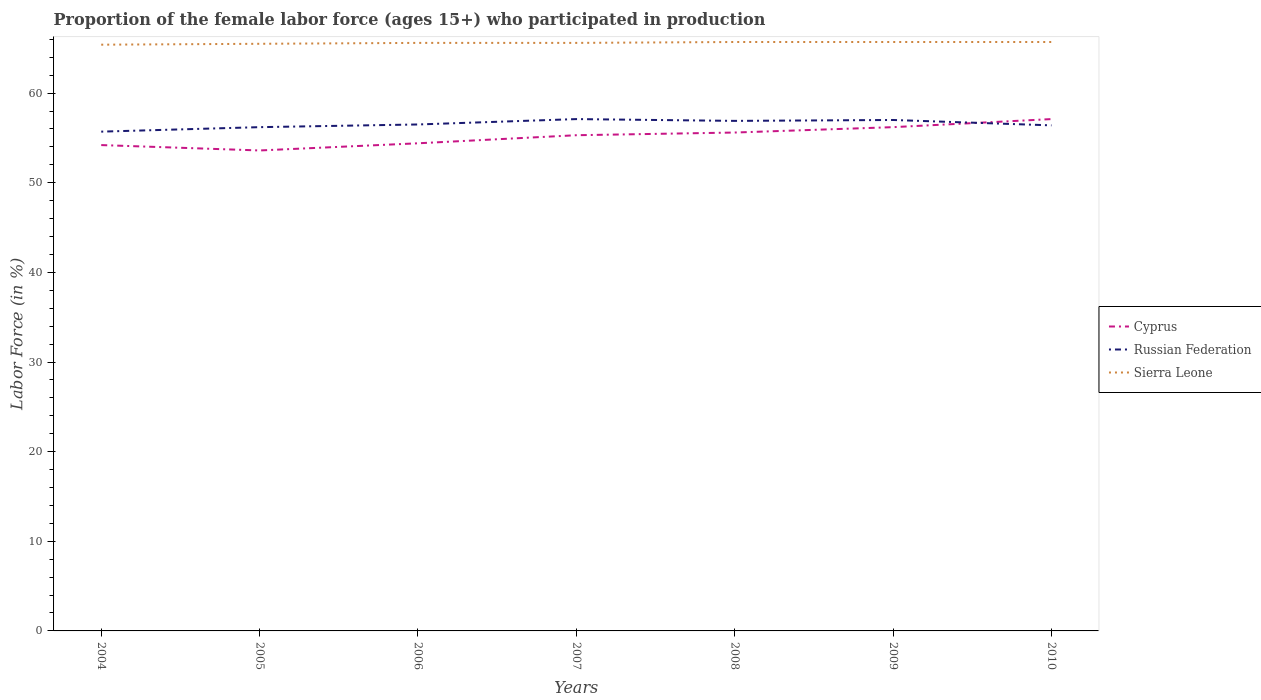How many different coloured lines are there?
Your answer should be very brief. 3. Across all years, what is the maximum proportion of the female labor force who participated in production in Russian Federation?
Keep it short and to the point. 55.7. In which year was the proportion of the female labor force who participated in production in Sierra Leone maximum?
Keep it short and to the point. 2004. What is the difference between the highest and the second highest proportion of the female labor force who participated in production in Cyprus?
Keep it short and to the point. 3.5. Is the proportion of the female labor force who participated in production in Cyprus strictly greater than the proportion of the female labor force who participated in production in Sierra Leone over the years?
Provide a short and direct response. Yes. How many lines are there?
Offer a terse response. 3. How many years are there in the graph?
Ensure brevity in your answer.  7. Are the values on the major ticks of Y-axis written in scientific E-notation?
Your answer should be compact. No. Does the graph contain grids?
Ensure brevity in your answer.  No. How are the legend labels stacked?
Provide a succinct answer. Vertical. What is the title of the graph?
Make the answer very short. Proportion of the female labor force (ages 15+) who participated in production. Does "United States" appear as one of the legend labels in the graph?
Offer a terse response. No. What is the label or title of the X-axis?
Your answer should be very brief. Years. What is the Labor Force (in %) in Cyprus in 2004?
Make the answer very short. 54.2. What is the Labor Force (in %) of Russian Federation in 2004?
Your response must be concise. 55.7. What is the Labor Force (in %) of Sierra Leone in 2004?
Your response must be concise. 65.4. What is the Labor Force (in %) of Cyprus in 2005?
Your answer should be compact. 53.6. What is the Labor Force (in %) in Russian Federation in 2005?
Your answer should be compact. 56.2. What is the Labor Force (in %) of Sierra Leone in 2005?
Provide a succinct answer. 65.5. What is the Labor Force (in %) of Cyprus in 2006?
Make the answer very short. 54.4. What is the Labor Force (in %) of Russian Federation in 2006?
Give a very brief answer. 56.5. What is the Labor Force (in %) in Sierra Leone in 2006?
Your answer should be compact. 65.6. What is the Labor Force (in %) in Cyprus in 2007?
Ensure brevity in your answer.  55.3. What is the Labor Force (in %) of Russian Federation in 2007?
Your answer should be compact. 57.1. What is the Labor Force (in %) in Sierra Leone in 2007?
Ensure brevity in your answer.  65.6. What is the Labor Force (in %) in Cyprus in 2008?
Make the answer very short. 55.6. What is the Labor Force (in %) in Russian Federation in 2008?
Make the answer very short. 56.9. What is the Labor Force (in %) of Sierra Leone in 2008?
Provide a succinct answer. 65.7. What is the Labor Force (in %) in Cyprus in 2009?
Offer a terse response. 56.2. What is the Labor Force (in %) of Sierra Leone in 2009?
Your answer should be compact. 65.7. What is the Labor Force (in %) in Cyprus in 2010?
Ensure brevity in your answer.  57.1. What is the Labor Force (in %) of Russian Federation in 2010?
Your answer should be compact. 56.4. What is the Labor Force (in %) of Sierra Leone in 2010?
Keep it short and to the point. 65.7. Across all years, what is the maximum Labor Force (in %) of Cyprus?
Provide a succinct answer. 57.1. Across all years, what is the maximum Labor Force (in %) in Russian Federation?
Offer a very short reply. 57.1. Across all years, what is the maximum Labor Force (in %) of Sierra Leone?
Your response must be concise. 65.7. Across all years, what is the minimum Labor Force (in %) in Cyprus?
Provide a succinct answer. 53.6. Across all years, what is the minimum Labor Force (in %) of Russian Federation?
Provide a short and direct response. 55.7. Across all years, what is the minimum Labor Force (in %) of Sierra Leone?
Give a very brief answer. 65.4. What is the total Labor Force (in %) of Cyprus in the graph?
Give a very brief answer. 386.4. What is the total Labor Force (in %) of Russian Federation in the graph?
Your answer should be very brief. 395.8. What is the total Labor Force (in %) in Sierra Leone in the graph?
Offer a very short reply. 459.2. What is the difference between the Labor Force (in %) in Cyprus in 2004 and that in 2005?
Offer a terse response. 0.6. What is the difference between the Labor Force (in %) in Sierra Leone in 2004 and that in 2005?
Give a very brief answer. -0.1. What is the difference between the Labor Force (in %) in Sierra Leone in 2004 and that in 2006?
Your answer should be very brief. -0.2. What is the difference between the Labor Force (in %) of Russian Federation in 2004 and that in 2009?
Keep it short and to the point. -1.3. What is the difference between the Labor Force (in %) in Cyprus in 2004 and that in 2010?
Offer a terse response. -2.9. What is the difference between the Labor Force (in %) in Sierra Leone in 2004 and that in 2010?
Offer a terse response. -0.3. What is the difference between the Labor Force (in %) of Cyprus in 2005 and that in 2006?
Make the answer very short. -0.8. What is the difference between the Labor Force (in %) in Cyprus in 2005 and that in 2007?
Your answer should be compact. -1.7. What is the difference between the Labor Force (in %) of Cyprus in 2005 and that in 2008?
Your answer should be very brief. -2. What is the difference between the Labor Force (in %) of Russian Federation in 2005 and that in 2008?
Give a very brief answer. -0.7. What is the difference between the Labor Force (in %) in Sierra Leone in 2005 and that in 2008?
Offer a terse response. -0.2. What is the difference between the Labor Force (in %) of Russian Federation in 2005 and that in 2010?
Provide a short and direct response. -0.2. What is the difference between the Labor Force (in %) of Cyprus in 2006 and that in 2008?
Provide a succinct answer. -1.2. What is the difference between the Labor Force (in %) of Russian Federation in 2006 and that in 2009?
Provide a succinct answer. -0.5. What is the difference between the Labor Force (in %) in Cyprus in 2006 and that in 2010?
Offer a terse response. -2.7. What is the difference between the Labor Force (in %) in Russian Federation in 2006 and that in 2010?
Make the answer very short. 0.1. What is the difference between the Labor Force (in %) of Cyprus in 2007 and that in 2008?
Your answer should be very brief. -0.3. What is the difference between the Labor Force (in %) of Russian Federation in 2007 and that in 2008?
Keep it short and to the point. 0.2. What is the difference between the Labor Force (in %) in Cyprus in 2007 and that in 2009?
Ensure brevity in your answer.  -0.9. What is the difference between the Labor Force (in %) in Russian Federation in 2007 and that in 2009?
Keep it short and to the point. 0.1. What is the difference between the Labor Force (in %) in Sierra Leone in 2007 and that in 2010?
Provide a short and direct response. -0.1. What is the difference between the Labor Force (in %) of Cyprus in 2008 and that in 2009?
Your answer should be compact. -0.6. What is the difference between the Labor Force (in %) of Sierra Leone in 2008 and that in 2009?
Your answer should be very brief. 0. What is the difference between the Labor Force (in %) of Cyprus in 2008 and that in 2010?
Offer a very short reply. -1.5. What is the difference between the Labor Force (in %) of Russian Federation in 2008 and that in 2010?
Offer a very short reply. 0.5. What is the difference between the Labor Force (in %) of Sierra Leone in 2008 and that in 2010?
Provide a succinct answer. 0. What is the difference between the Labor Force (in %) of Cyprus in 2009 and that in 2010?
Your response must be concise. -0.9. What is the difference between the Labor Force (in %) in Cyprus in 2004 and the Labor Force (in %) in Russian Federation in 2006?
Your answer should be very brief. -2.3. What is the difference between the Labor Force (in %) of Cyprus in 2004 and the Labor Force (in %) of Russian Federation in 2007?
Provide a succinct answer. -2.9. What is the difference between the Labor Force (in %) in Russian Federation in 2004 and the Labor Force (in %) in Sierra Leone in 2007?
Provide a succinct answer. -9.9. What is the difference between the Labor Force (in %) in Cyprus in 2004 and the Labor Force (in %) in Russian Federation in 2008?
Give a very brief answer. -2.7. What is the difference between the Labor Force (in %) in Cyprus in 2004 and the Labor Force (in %) in Sierra Leone in 2009?
Make the answer very short. -11.5. What is the difference between the Labor Force (in %) in Russian Federation in 2004 and the Labor Force (in %) in Sierra Leone in 2010?
Provide a succinct answer. -10. What is the difference between the Labor Force (in %) in Cyprus in 2005 and the Labor Force (in %) in Sierra Leone in 2007?
Your answer should be compact. -12. What is the difference between the Labor Force (in %) of Russian Federation in 2005 and the Labor Force (in %) of Sierra Leone in 2007?
Give a very brief answer. -9.4. What is the difference between the Labor Force (in %) in Russian Federation in 2005 and the Labor Force (in %) in Sierra Leone in 2008?
Your response must be concise. -9.5. What is the difference between the Labor Force (in %) in Cyprus in 2005 and the Labor Force (in %) in Sierra Leone in 2009?
Your response must be concise. -12.1. What is the difference between the Labor Force (in %) of Cyprus in 2005 and the Labor Force (in %) of Russian Federation in 2010?
Your answer should be compact. -2.8. What is the difference between the Labor Force (in %) in Cyprus in 2006 and the Labor Force (in %) in Russian Federation in 2007?
Keep it short and to the point. -2.7. What is the difference between the Labor Force (in %) of Cyprus in 2006 and the Labor Force (in %) of Sierra Leone in 2007?
Offer a very short reply. -11.2. What is the difference between the Labor Force (in %) in Cyprus in 2006 and the Labor Force (in %) in Russian Federation in 2008?
Offer a very short reply. -2.5. What is the difference between the Labor Force (in %) of Cyprus in 2006 and the Labor Force (in %) of Sierra Leone in 2008?
Provide a succinct answer. -11.3. What is the difference between the Labor Force (in %) of Cyprus in 2006 and the Labor Force (in %) of Sierra Leone in 2009?
Provide a short and direct response. -11.3. What is the difference between the Labor Force (in %) in Russian Federation in 2006 and the Labor Force (in %) in Sierra Leone in 2009?
Offer a terse response. -9.2. What is the difference between the Labor Force (in %) of Russian Federation in 2006 and the Labor Force (in %) of Sierra Leone in 2010?
Provide a short and direct response. -9.2. What is the difference between the Labor Force (in %) of Russian Federation in 2007 and the Labor Force (in %) of Sierra Leone in 2008?
Ensure brevity in your answer.  -8.6. What is the difference between the Labor Force (in %) of Cyprus in 2007 and the Labor Force (in %) of Russian Federation in 2009?
Give a very brief answer. -1.7. What is the difference between the Labor Force (in %) of Cyprus in 2007 and the Labor Force (in %) of Sierra Leone in 2009?
Offer a very short reply. -10.4. What is the difference between the Labor Force (in %) of Russian Federation in 2007 and the Labor Force (in %) of Sierra Leone in 2009?
Make the answer very short. -8.6. What is the difference between the Labor Force (in %) of Cyprus in 2007 and the Labor Force (in %) of Russian Federation in 2010?
Your answer should be compact. -1.1. What is the difference between the Labor Force (in %) of Russian Federation in 2008 and the Labor Force (in %) of Sierra Leone in 2009?
Provide a short and direct response. -8.8. What is the difference between the Labor Force (in %) of Cyprus in 2008 and the Labor Force (in %) of Russian Federation in 2010?
Your response must be concise. -0.8. What is the difference between the Labor Force (in %) in Cyprus in 2008 and the Labor Force (in %) in Sierra Leone in 2010?
Your answer should be compact. -10.1. What is the difference between the Labor Force (in %) in Cyprus in 2009 and the Labor Force (in %) in Sierra Leone in 2010?
Your response must be concise. -9.5. What is the average Labor Force (in %) of Cyprus per year?
Your answer should be very brief. 55.2. What is the average Labor Force (in %) of Russian Federation per year?
Keep it short and to the point. 56.54. What is the average Labor Force (in %) of Sierra Leone per year?
Keep it short and to the point. 65.6. In the year 2005, what is the difference between the Labor Force (in %) of Russian Federation and Labor Force (in %) of Sierra Leone?
Your answer should be compact. -9.3. In the year 2008, what is the difference between the Labor Force (in %) in Cyprus and Labor Force (in %) in Sierra Leone?
Offer a terse response. -10.1. In the year 2008, what is the difference between the Labor Force (in %) of Russian Federation and Labor Force (in %) of Sierra Leone?
Offer a terse response. -8.8. In the year 2009, what is the difference between the Labor Force (in %) in Russian Federation and Labor Force (in %) in Sierra Leone?
Make the answer very short. -8.7. In the year 2010, what is the difference between the Labor Force (in %) of Cyprus and Labor Force (in %) of Russian Federation?
Your answer should be very brief. 0.7. In the year 2010, what is the difference between the Labor Force (in %) in Cyprus and Labor Force (in %) in Sierra Leone?
Provide a succinct answer. -8.6. In the year 2010, what is the difference between the Labor Force (in %) of Russian Federation and Labor Force (in %) of Sierra Leone?
Provide a succinct answer. -9.3. What is the ratio of the Labor Force (in %) in Cyprus in 2004 to that in 2005?
Give a very brief answer. 1.01. What is the ratio of the Labor Force (in %) of Russian Federation in 2004 to that in 2005?
Ensure brevity in your answer.  0.99. What is the ratio of the Labor Force (in %) of Sierra Leone in 2004 to that in 2005?
Your answer should be compact. 1. What is the ratio of the Labor Force (in %) of Cyprus in 2004 to that in 2006?
Make the answer very short. 1. What is the ratio of the Labor Force (in %) of Russian Federation in 2004 to that in 2006?
Offer a terse response. 0.99. What is the ratio of the Labor Force (in %) of Cyprus in 2004 to that in 2007?
Offer a very short reply. 0.98. What is the ratio of the Labor Force (in %) in Russian Federation in 2004 to that in 2007?
Provide a succinct answer. 0.98. What is the ratio of the Labor Force (in %) in Sierra Leone in 2004 to that in 2007?
Provide a short and direct response. 1. What is the ratio of the Labor Force (in %) of Cyprus in 2004 to that in 2008?
Provide a short and direct response. 0.97. What is the ratio of the Labor Force (in %) in Russian Federation in 2004 to that in 2008?
Keep it short and to the point. 0.98. What is the ratio of the Labor Force (in %) of Sierra Leone in 2004 to that in 2008?
Make the answer very short. 1. What is the ratio of the Labor Force (in %) in Cyprus in 2004 to that in 2009?
Offer a terse response. 0.96. What is the ratio of the Labor Force (in %) in Russian Federation in 2004 to that in 2009?
Your response must be concise. 0.98. What is the ratio of the Labor Force (in %) in Cyprus in 2004 to that in 2010?
Your answer should be very brief. 0.95. What is the ratio of the Labor Force (in %) in Russian Federation in 2004 to that in 2010?
Make the answer very short. 0.99. What is the ratio of the Labor Force (in %) of Cyprus in 2005 to that in 2006?
Make the answer very short. 0.99. What is the ratio of the Labor Force (in %) of Russian Federation in 2005 to that in 2006?
Give a very brief answer. 0.99. What is the ratio of the Labor Force (in %) in Cyprus in 2005 to that in 2007?
Provide a short and direct response. 0.97. What is the ratio of the Labor Force (in %) in Russian Federation in 2005 to that in 2007?
Keep it short and to the point. 0.98. What is the ratio of the Labor Force (in %) in Cyprus in 2005 to that in 2009?
Keep it short and to the point. 0.95. What is the ratio of the Labor Force (in %) of Sierra Leone in 2005 to that in 2009?
Your response must be concise. 1. What is the ratio of the Labor Force (in %) in Cyprus in 2005 to that in 2010?
Offer a terse response. 0.94. What is the ratio of the Labor Force (in %) in Russian Federation in 2005 to that in 2010?
Your answer should be compact. 1. What is the ratio of the Labor Force (in %) of Sierra Leone in 2005 to that in 2010?
Offer a terse response. 1. What is the ratio of the Labor Force (in %) of Cyprus in 2006 to that in 2007?
Ensure brevity in your answer.  0.98. What is the ratio of the Labor Force (in %) of Sierra Leone in 2006 to that in 2007?
Give a very brief answer. 1. What is the ratio of the Labor Force (in %) in Cyprus in 2006 to that in 2008?
Ensure brevity in your answer.  0.98. What is the ratio of the Labor Force (in %) of Russian Federation in 2006 to that in 2008?
Ensure brevity in your answer.  0.99. What is the ratio of the Labor Force (in %) of Sierra Leone in 2006 to that in 2008?
Offer a very short reply. 1. What is the ratio of the Labor Force (in %) of Cyprus in 2006 to that in 2009?
Keep it short and to the point. 0.97. What is the ratio of the Labor Force (in %) of Russian Federation in 2006 to that in 2009?
Your response must be concise. 0.99. What is the ratio of the Labor Force (in %) in Sierra Leone in 2006 to that in 2009?
Offer a very short reply. 1. What is the ratio of the Labor Force (in %) in Cyprus in 2006 to that in 2010?
Offer a very short reply. 0.95. What is the ratio of the Labor Force (in %) in Sierra Leone in 2007 to that in 2008?
Your answer should be very brief. 1. What is the ratio of the Labor Force (in %) of Russian Federation in 2007 to that in 2009?
Your answer should be very brief. 1. What is the ratio of the Labor Force (in %) in Cyprus in 2007 to that in 2010?
Ensure brevity in your answer.  0.97. What is the ratio of the Labor Force (in %) of Russian Federation in 2007 to that in 2010?
Offer a very short reply. 1.01. What is the ratio of the Labor Force (in %) of Cyprus in 2008 to that in 2009?
Provide a succinct answer. 0.99. What is the ratio of the Labor Force (in %) in Cyprus in 2008 to that in 2010?
Give a very brief answer. 0.97. What is the ratio of the Labor Force (in %) in Russian Federation in 2008 to that in 2010?
Ensure brevity in your answer.  1.01. What is the ratio of the Labor Force (in %) of Cyprus in 2009 to that in 2010?
Provide a short and direct response. 0.98. What is the ratio of the Labor Force (in %) in Russian Federation in 2009 to that in 2010?
Offer a terse response. 1.01. What is the difference between the highest and the second highest Labor Force (in %) in Russian Federation?
Provide a short and direct response. 0.1. What is the difference between the highest and the second highest Labor Force (in %) in Sierra Leone?
Provide a succinct answer. 0. What is the difference between the highest and the lowest Labor Force (in %) in Cyprus?
Keep it short and to the point. 3.5. What is the difference between the highest and the lowest Labor Force (in %) of Russian Federation?
Your response must be concise. 1.4. What is the difference between the highest and the lowest Labor Force (in %) of Sierra Leone?
Provide a short and direct response. 0.3. 